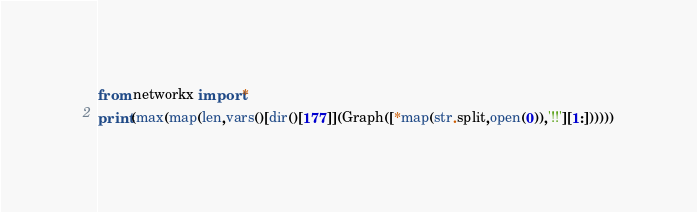<code> <loc_0><loc_0><loc_500><loc_500><_Cython_>from networkx import*
print(max(map(len,vars()[dir()[177]](Graph([*map(str.split,open(0)),'!!'][1:])))))</code> 